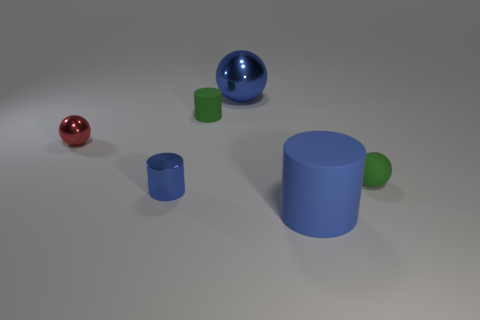Do the blue object that is behind the green sphere and the green cylinder have the same material?
Offer a very short reply. No. What is the blue thing that is behind the big matte object and in front of the green cylinder made of?
Ensure brevity in your answer.  Metal. What is the color of the tiny rubber object in front of the matte cylinder that is behind the tiny red metal object?
Offer a very short reply. Green. There is another blue object that is the same shape as the small blue shiny thing; what is it made of?
Your answer should be compact. Rubber. There is a sphere that is on the left side of the blue shiny object that is in front of the green object that is to the left of the big blue metallic object; what color is it?
Provide a short and direct response. Red. How many objects are rubber cylinders or large blue shiny spheres?
Your answer should be very brief. 3. How many big red rubber objects have the same shape as the tiny blue thing?
Offer a terse response. 0. Are the green ball and the big object that is in front of the tiny matte ball made of the same material?
Keep it short and to the point. Yes. There is a blue cylinder that is the same material as the large blue ball; what is its size?
Give a very brief answer. Small. What size is the blue cylinder that is in front of the blue metallic cylinder?
Offer a terse response. Large. 